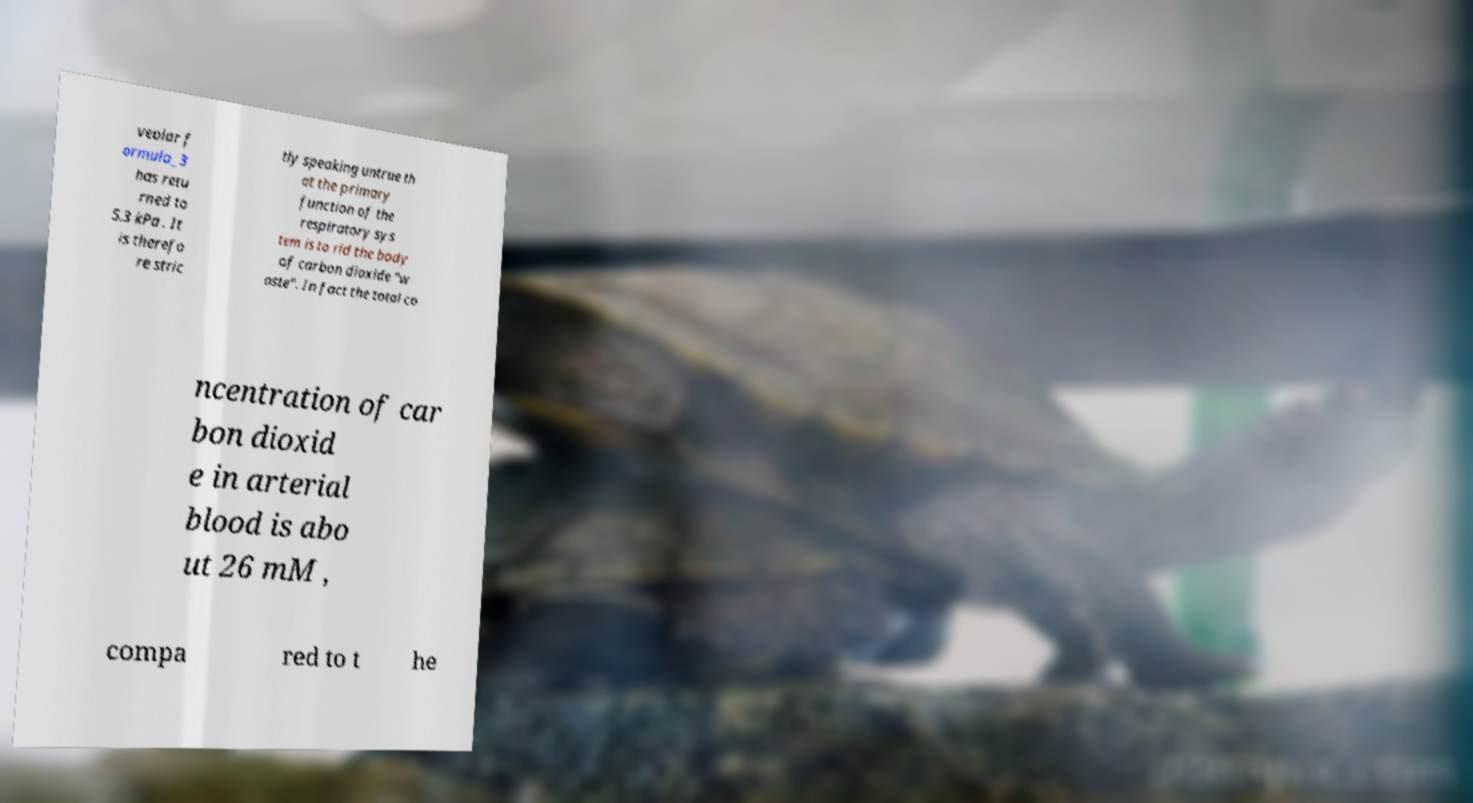What messages or text are displayed in this image? I need them in a readable, typed format. veolar f ormula_3 has retu rned to 5.3 kPa . It is therefo re stric tly speaking untrue th at the primary function of the respiratory sys tem is to rid the body of carbon dioxide "w aste". In fact the total co ncentration of car bon dioxid e in arterial blood is abo ut 26 mM , compa red to t he 